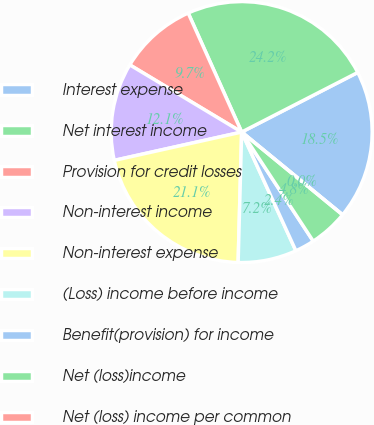Convert chart to OTSL. <chart><loc_0><loc_0><loc_500><loc_500><pie_chart><fcel>Interest expense<fcel>Net interest income<fcel>Provision for credit losses<fcel>Non-interest income<fcel>Non-interest expense<fcel>(Loss) income before income<fcel>Benefit(provision) for income<fcel>Net (loss)income<fcel>Net (loss) income per common<nl><fcel>18.48%<fcel>24.17%<fcel>9.67%<fcel>12.09%<fcel>21.09%<fcel>7.25%<fcel>2.42%<fcel>4.83%<fcel>0.0%<nl></chart> 